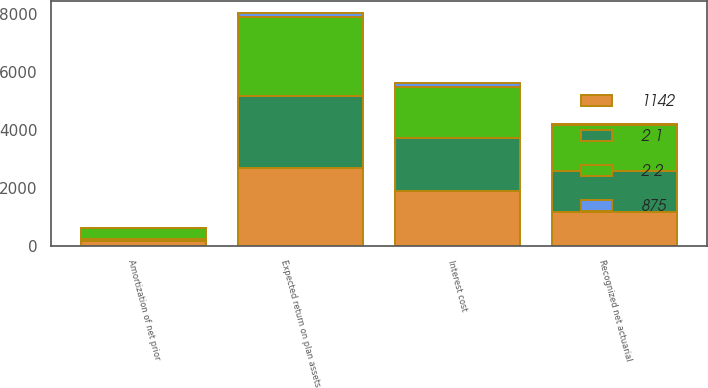<chart> <loc_0><loc_0><loc_500><loc_500><stacked_bar_chart><ecel><fcel>Interest cost<fcel>Expected return on plan assets<fcel>Recognized net actuarial<fcel>Amortization of net prior<nl><fcel>2 2<fcel>1791<fcel>2734<fcel>1599<fcel>389<nl><fcel>1142<fcel>1912<fcel>2693<fcel>1173<fcel>151<nl><fcel>2 1<fcel>1800<fcel>2485<fcel>1410<fcel>81<nl><fcel>875<fcel>110<fcel>147<fcel>43<fcel>4<nl></chart> 